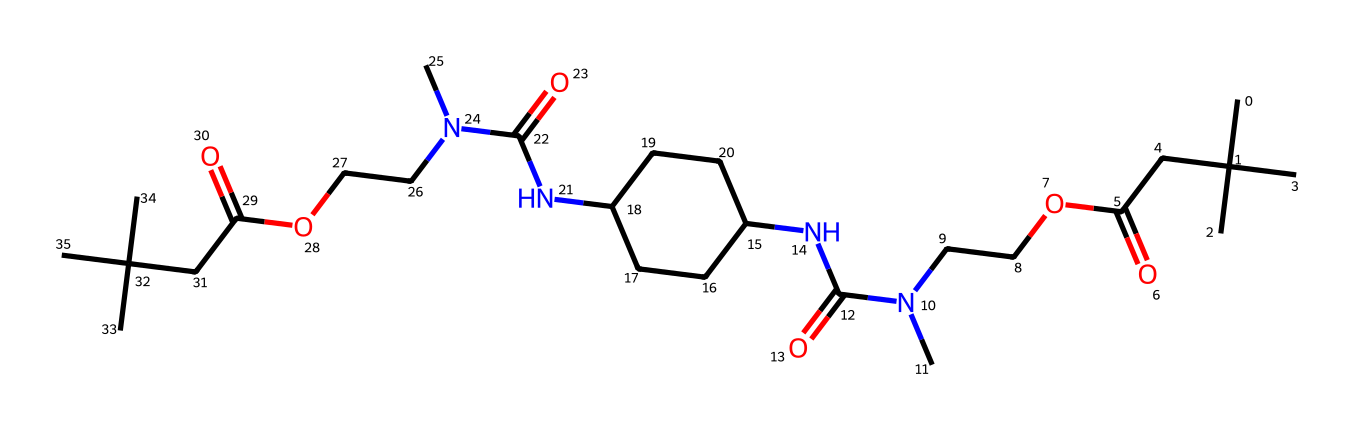What type of polymer is represented by this structure? The presence of multiple amide linkages (–CO–NH–) indicates that this polymer is a type of polyurethane. Polyurethanes are formed from the reaction of diisocyanates with polyols, and the structure reveals these characteristics.
Answer: polyurethane How many nitrogen atoms are present in the structure? By examining the SMILES representation, we can count the nitrogen atoms, which appear at specific points in the chain. In this case, there are three distinct nitrogen atoms.
Answer: 3 What type of functional groups are prominent in this polymer? Observing the chemical structure, we can identify several functional groups: esters (–COO–) and amides (–CONH–) are notably present, which are characteristic of polyurethanes. The esters come from the polyol, while the amides come from the isocyanate component.
Answer: esters and amides What is the backbone of this polymer primarily composed of? The backbone of the polymer is primarily composed of carbon atoms (C). The carbon skeleton serves as the main chain to which functional groups such as amides and esters are attached.
Answer: carbon atoms What property of the polymer might be influenced by its branching structure? The branching structure of this polymer can influence its flexibility and strength. More branching often leads to increased flexibility, which is beneficial in applications such as football cleats where mobility is essential.
Answer: flexibility 